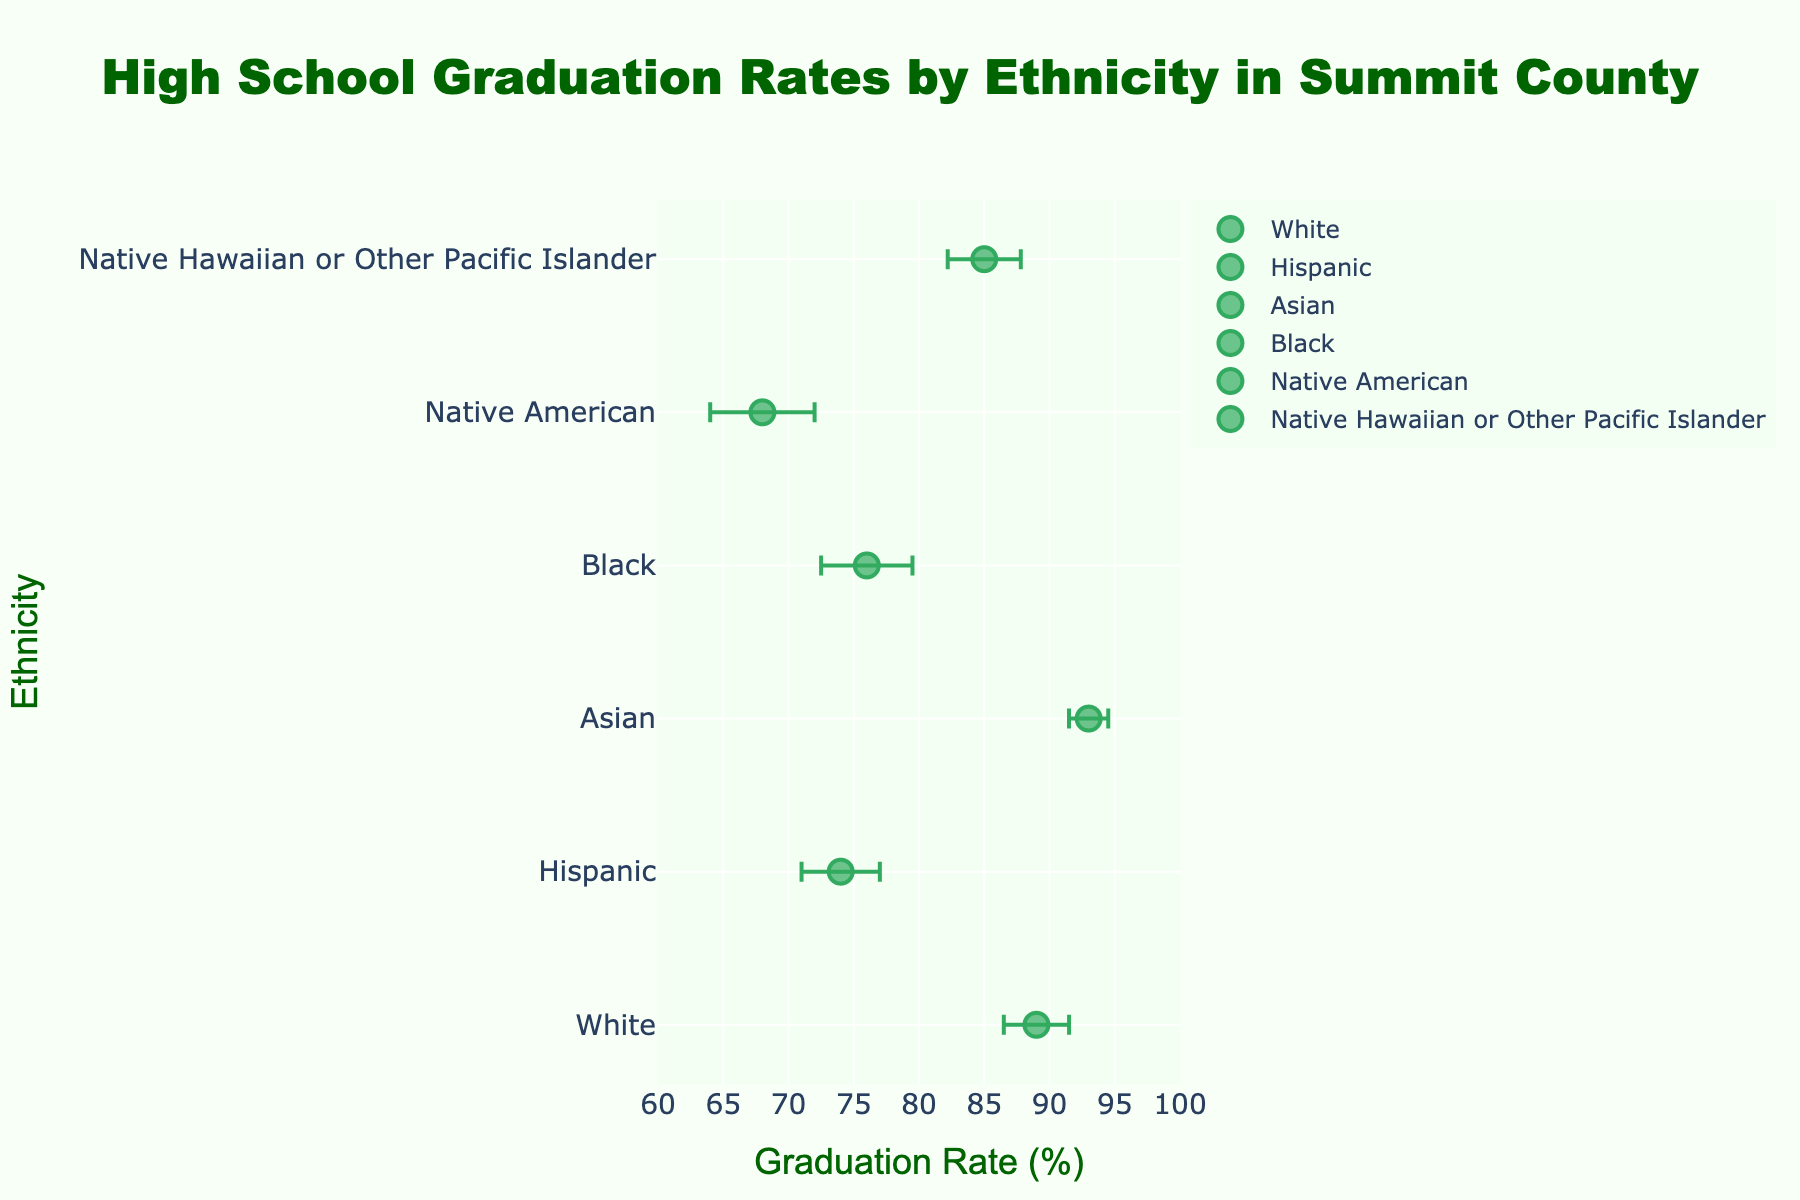What is the title of the figure? The title of the figure is located at the top center of the plot, presenting an overview of what the data represents. In this case, it reads "High School Graduation Rates by Ethnicity in Summit County".
Answer: High School Graduation Rates by Ethnicity in Summit County Which ethnic group has the highest high school graduation rate? To determine the highest graduation rate, identify the data point with the highest value on the x-axis. The Asian group has a graduation rate of 93%, which is the highest among all ethnic groups.
Answer: Asian What is the graduation rate for the Hispanic group? Locate the Hispanic group on the y-axis and read the corresponding value on the x-axis. The Hispanic group's graduation rate is 74%.
Answer: 74% Which ethnic group has the largest error margin, and what is that margin? To find the largest error margin, compare the error margins associated with each data point. The Native American group has the largest error margin of 4.0%.
Answer: Native American, 4.0% What is the difference between the graduation rates of the White and Black groups? Subtract the graduation rate of the Black group (76%) from the graduation rate of the White group (89%). The difference is 89% - 76% = 13%.
Answer: 13% Among the ethnic groups, which two have the closest graduation rates and what are those rates? Compare each pair of ethnic groups to find the smallest difference in graduation rates. The White (89%) and Native Hawaiian or Other Pacific Islander (85%) groups have the closest graduation rates, with a difference of only 4%.
Answer: White (89%) and Native Hawaiian or Other Pacific Islander (85%) Which group has a higher graduation rate, Black or Hispanic, and by how much? Compare the graduation rates of the Black (76%) and Hispanic (74%) groups. The Black group has a higher rate. Subtract the Hispanic rate from the Black rate: 76% - 74% = 2%.
Answer: Black, by 2% What is the range of graduation rates observed in the figure? Determine the highest and lowest graduation rates and calculate the difference. The highest rate is 93% (Asian) and the lowest is 68% (Native American). The range is 93% - 68% = 25%.
Answer: 25% Which ethnic group has the smallest error margin and what is it? Identify the data point with the smallest error bar. The Asian group has the smallest error margin of 1.5%.
Answer: Asian, 1.5% What can be inferred about the consistency of graduation rates within the Native American group compared to the Asian group? Larger error margins indicate greater variability. The Native American group has an error margin of 4.0%, while the Asian group has a margin of 1.5%, suggesting that the graduation rates within the Native American group are less consistent than those of the Asian group.
Answer: Less consistent for Native American compared to Asian 